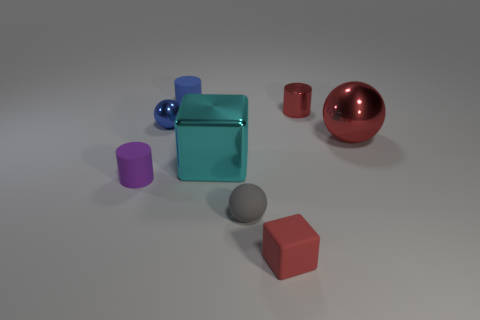Are there any other things that are made of the same material as the blue ball?
Keep it short and to the point. Yes. What number of tiny objects are to the right of the big cyan block and in front of the blue metallic ball?
Ensure brevity in your answer.  2. How many objects are tiny red things behind the large metal cube or metal objects that are on the left side of the red metal cylinder?
Offer a terse response. 3. How many other things are the same shape as the big cyan metal thing?
Your response must be concise. 1. There is a small metallic ball that is behind the tiny gray thing; is it the same color as the metallic cube?
Give a very brief answer. No. How many other objects are the same size as the purple cylinder?
Provide a short and direct response. 5. Do the purple object and the red ball have the same material?
Your response must be concise. No. What color is the block that is in front of the small cylinder on the left side of the tiny blue shiny ball?
Make the answer very short. Red. There is a blue object that is the same shape as the tiny gray matte object; what is its size?
Make the answer very short. Small. Is the large block the same color as the small metal cylinder?
Ensure brevity in your answer.  No. 